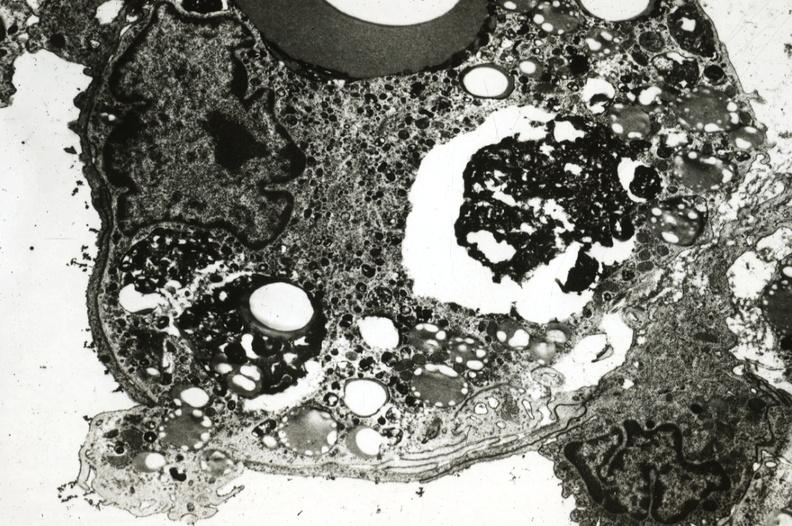s atherosclerosis present?
Answer the question using a single word or phrase. Yes 